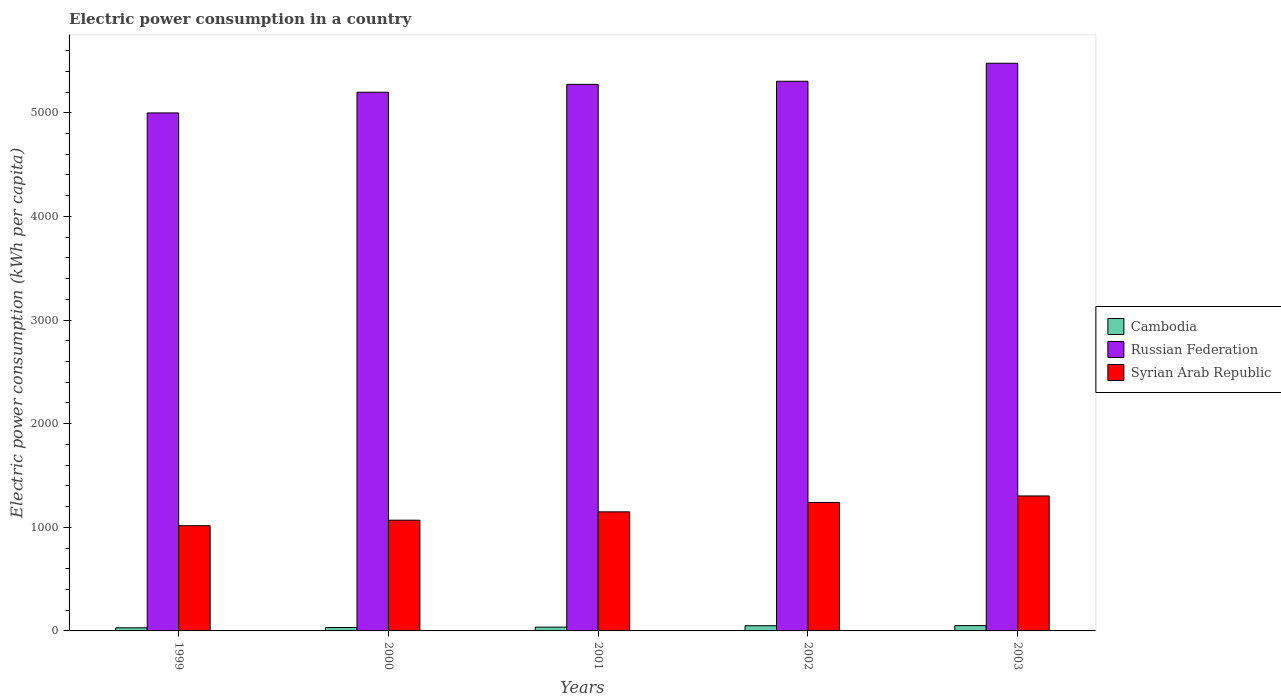How many different coloured bars are there?
Your response must be concise. 3. Are the number of bars on each tick of the X-axis equal?
Ensure brevity in your answer.  Yes. How many bars are there on the 3rd tick from the right?
Keep it short and to the point. 3. What is the electric power consumption in in Russian Federation in 2003?
Provide a succinct answer. 5478.14. Across all years, what is the maximum electric power consumption in in Cambodia?
Your response must be concise. 51.31. Across all years, what is the minimum electric power consumption in in Syrian Arab Republic?
Keep it short and to the point. 1015.69. In which year was the electric power consumption in in Syrian Arab Republic minimum?
Give a very brief answer. 1999. What is the total electric power consumption in in Syrian Arab Republic in the graph?
Keep it short and to the point. 5775.81. What is the difference between the electric power consumption in in Syrian Arab Republic in 2000 and that in 2001?
Offer a very short reply. -80.52. What is the difference between the electric power consumption in in Russian Federation in 2001 and the electric power consumption in in Cambodia in 2002?
Ensure brevity in your answer.  5224.23. What is the average electric power consumption in in Cambodia per year?
Ensure brevity in your answer.  40.12. In the year 2001, what is the difference between the electric power consumption in in Cambodia and electric power consumption in in Syrian Arab Republic?
Provide a succinct answer. -1112.74. In how many years, is the electric power consumption in in Russian Federation greater than 4600 kWh per capita?
Offer a very short reply. 5. What is the ratio of the electric power consumption in in Cambodia in 2000 to that in 2001?
Give a very brief answer. 0.9. What is the difference between the highest and the second highest electric power consumption in in Cambodia?
Provide a succinct answer. 1.16. What is the difference between the highest and the lowest electric power consumption in in Cambodia?
Keep it short and to the point. 21.22. Is the sum of the electric power consumption in in Russian Federation in 2000 and 2003 greater than the maximum electric power consumption in in Cambodia across all years?
Offer a terse response. Yes. What does the 2nd bar from the left in 2001 represents?
Your answer should be compact. Russian Federation. What does the 2nd bar from the right in 2003 represents?
Your answer should be very brief. Russian Federation. How many bars are there?
Your answer should be compact. 15. Are all the bars in the graph horizontal?
Ensure brevity in your answer.  No. How many years are there in the graph?
Make the answer very short. 5. What is the difference between two consecutive major ticks on the Y-axis?
Offer a very short reply. 1000. Does the graph contain any zero values?
Provide a succinct answer. No. Where does the legend appear in the graph?
Ensure brevity in your answer.  Center right. What is the title of the graph?
Offer a very short reply. Electric power consumption in a country. Does "Congo (Democratic)" appear as one of the legend labels in the graph?
Offer a terse response. No. What is the label or title of the X-axis?
Your answer should be very brief. Years. What is the label or title of the Y-axis?
Provide a short and direct response. Electric power consumption (kWh per capita). What is the Electric power consumption (kWh per capita) of Cambodia in 1999?
Keep it short and to the point. 30.1. What is the Electric power consumption (kWh per capita) of Russian Federation in 1999?
Your answer should be compact. 4998.84. What is the Electric power consumption (kWh per capita) of Syrian Arab Republic in 1999?
Ensure brevity in your answer.  1015.69. What is the Electric power consumption (kWh per capita) of Cambodia in 2000?
Keep it short and to the point. 32.63. What is the Electric power consumption (kWh per capita) in Russian Federation in 2000?
Your answer should be very brief. 5198.42. What is the Electric power consumption (kWh per capita) in Syrian Arab Republic in 2000?
Your answer should be compact. 1068.6. What is the Electric power consumption (kWh per capita) of Cambodia in 2001?
Provide a succinct answer. 36.39. What is the Electric power consumption (kWh per capita) in Russian Federation in 2001?
Offer a terse response. 5274.38. What is the Electric power consumption (kWh per capita) of Syrian Arab Republic in 2001?
Your response must be concise. 1149.13. What is the Electric power consumption (kWh per capita) of Cambodia in 2002?
Provide a succinct answer. 50.15. What is the Electric power consumption (kWh per capita) of Russian Federation in 2002?
Offer a terse response. 5304.43. What is the Electric power consumption (kWh per capita) of Syrian Arab Republic in 2002?
Give a very brief answer. 1239.89. What is the Electric power consumption (kWh per capita) in Cambodia in 2003?
Your answer should be very brief. 51.31. What is the Electric power consumption (kWh per capita) in Russian Federation in 2003?
Make the answer very short. 5478.14. What is the Electric power consumption (kWh per capita) of Syrian Arab Republic in 2003?
Make the answer very short. 1302.51. Across all years, what is the maximum Electric power consumption (kWh per capita) of Cambodia?
Your response must be concise. 51.31. Across all years, what is the maximum Electric power consumption (kWh per capita) of Russian Federation?
Give a very brief answer. 5478.14. Across all years, what is the maximum Electric power consumption (kWh per capita) of Syrian Arab Republic?
Your answer should be compact. 1302.51. Across all years, what is the minimum Electric power consumption (kWh per capita) of Cambodia?
Make the answer very short. 30.1. Across all years, what is the minimum Electric power consumption (kWh per capita) in Russian Federation?
Offer a very short reply. 4998.84. Across all years, what is the minimum Electric power consumption (kWh per capita) of Syrian Arab Republic?
Provide a short and direct response. 1015.69. What is the total Electric power consumption (kWh per capita) in Cambodia in the graph?
Your response must be concise. 200.58. What is the total Electric power consumption (kWh per capita) in Russian Federation in the graph?
Your answer should be very brief. 2.63e+04. What is the total Electric power consumption (kWh per capita) in Syrian Arab Republic in the graph?
Make the answer very short. 5775.81. What is the difference between the Electric power consumption (kWh per capita) in Cambodia in 1999 and that in 2000?
Provide a succinct answer. -2.53. What is the difference between the Electric power consumption (kWh per capita) in Russian Federation in 1999 and that in 2000?
Offer a very short reply. -199.58. What is the difference between the Electric power consumption (kWh per capita) in Syrian Arab Republic in 1999 and that in 2000?
Your response must be concise. -52.92. What is the difference between the Electric power consumption (kWh per capita) in Cambodia in 1999 and that in 2001?
Provide a short and direct response. -6.29. What is the difference between the Electric power consumption (kWh per capita) in Russian Federation in 1999 and that in 2001?
Provide a short and direct response. -275.54. What is the difference between the Electric power consumption (kWh per capita) in Syrian Arab Republic in 1999 and that in 2001?
Offer a very short reply. -133.44. What is the difference between the Electric power consumption (kWh per capita) of Cambodia in 1999 and that in 2002?
Your response must be concise. -20.05. What is the difference between the Electric power consumption (kWh per capita) of Russian Federation in 1999 and that in 2002?
Provide a short and direct response. -305.59. What is the difference between the Electric power consumption (kWh per capita) in Syrian Arab Republic in 1999 and that in 2002?
Give a very brief answer. -224.2. What is the difference between the Electric power consumption (kWh per capita) of Cambodia in 1999 and that in 2003?
Provide a succinct answer. -21.22. What is the difference between the Electric power consumption (kWh per capita) of Russian Federation in 1999 and that in 2003?
Provide a short and direct response. -479.31. What is the difference between the Electric power consumption (kWh per capita) in Syrian Arab Republic in 1999 and that in 2003?
Provide a short and direct response. -286.82. What is the difference between the Electric power consumption (kWh per capita) of Cambodia in 2000 and that in 2001?
Offer a very short reply. -3.76. What is the difference between the Electric power consumption (kWh per capita) of Russian Federation in 2000 and that in 2001?
Ensure brevity in your answer.  -75.96. What is the difference between the Electric power consumption (kWh per capita) of Syrian Arab Republic in 2000 and that in 2001?
Give a very brief answer. -80.52. What is the difference between the Electric power consumption (kWh per capita) in Cambodia in 2000 and that in 2002?
Provide a short and direct response. -17.52. What is the difference between the Electric power consumption (kWh per capita) of Russian Federation in 2000 and that in 2002?
Your response must be concise. -106.02. What is the difference between the Electric power consumption (kWh per capita) in Syrian Arab Republic in 2000 and that in 2002?
Keep it short and to the point. -171.28. What is the difference between the Electric power consumption (kWh per capita) of Cambodia in 2000 and that in 2003?
Your answer should be compact. -18.68. What is the difference between the Electric power consumption (kWh per capita) in Russian Federation in 2000 and that in 2003?
Offer a very short reply. -279.73. What is the difference between the Electric power consumption (kWh per capita) in Syrian Arab Republic in 2000 and that in 2003?
Offer a terse response. -233.9. What is the difference between the Electric power consumption (kWh per capita) in Cambodia in 2001 and that in 2002?
Your response must be concise. -13.76. What is the difference between the Electric power consumption (kWh per capita) of Russian Federation in 2001 and that in 2002?
Provide a short and direct response. -30.05. What is the difference between the Electric power consumption (kWh per capita) of Syrian Arab Republic in 2001 and that in 2002?
Provide a succinct answer. -90.76. What is the difference between the Electric power consumption (kWh per capita) of Cambodia in 2001 and that in 2003?
Offer a terse response. -14.92. What is the difference between the Electric power consumption (kWh per capita) of Russian Federation in 2001 and that in 2003?
Offer a very short reply. -203.77. What is the difference between the Electric power consumption (kWh per capita) in Syrian Arab Republic in 2001 and that in 2003?
Keep it short and to the point. -153.38. What is the difference between the Electric power consumption (kWh per capita) of Cambodia in 2002 and that in 2003?
Ensure brevity in your answer.  -1.16. What is the difference between the Electric power consumption (kWh per capita) of Russian Federation in 2002 and that in 2003?
Keep it short and to the point. -173.71. What is the difference between the Electric power consumption (kWh per capita) in Syrian Arab Republic in 2002 and that in 2003?
Ensure brevity in your answer.  -62.62. What is the difference between the Electric power consumption (kWh per capita) of Cambodia in 1999 and the Electric power consumption (kWh per capita) of Russian Federation in 2000?
Give a very brief answer. -5168.32. What is the difference between the Electric power consumption (kWh per capita) in Cambodia in 1999 and the Electric power consumption (kWh per capita) in Syrian Arab Republic in 2000?
Keep it short and to the point. -1038.51. What is the difference between the Electric power consumption (kWh per capita) in Russian Federation in 1999 and the Electric power consumption (kWh per capita) in Syrian Arab Republic in 2000?
Provide a succinct answer. 3930.23. What is the difference between the Electric power consumption (kWh per capita) in Cambodia in 1999 and the Electric power consumption (kWh per capita) in Russian Federation in 2001?
Provide a succinct answer. -5244.28. What is the difference between the Electric power consumption (kWh per capita) of Cambodia in 1999 and the Electric power consumption (kWh per capita) of Syrian Arab Republic in 2001?
Keep it short and to the point. -1119.03. What is the difference between the Electric power consumption (kWh per capita) in Russian Federation in 1999 and the Electric power consumption (kWh per capita) in Syrian Arab Republic in 2001?
Offer a very short reply. 3849.71. What is the difference between the Electric power consumption (kWh per capita) of Cambodia in 1999 and the Electric power consumption (kWh per capita) of Russian Federation in 2002?
Make the answer very short. -5274.34. What is the difference between the Electric power consumption (kWh per capita) of Cambodia in 1999 and the Electric power consumption (kWh per capita) of Syrian Arab Republic in 2002?
Your response must be concise. -1209.79. What is the difference between the Electric power consumption (kWh per capita) in Russian Federation in 1999 and the Electric power consumption (kWh per capita) in Syrian Arab Republic in 2002?
Keep it short and to the point. 3758.95. What is the difference between the Electric power consumption (kWh per capita) in Cambodia in 1999 and the Electric power consumption (kWh per capita) in Russian Federation in 2003?
Your answer should be very brief. -5448.05. What is the difference between the Electric power consumption (kWh per capita) in Cambodia in 1999 and the Electric power consumption (kWh per capita) in Syrian Arab Republic in 2003?
Your response must be concise. -1272.41. What is the difference between the Electric power consumption (kWh per capita) of Russian Federation in 1999 and the Electric power consumption (kWh per capita) of Syrian Arab Republic in 2003?
Offer a very short reply. 3696.33. What is the difference between the Electric power consumption (kWh per capita) of Cambodia in 2000 and the Electric power consumption (kWh per capita) of Russian Federation in 2001?
Make the answer very short. -5241.75. What is the difference between the Electric power consumption (kWh per capita) in Cambodia in 2000 and the Electric power consumption (kWh per capita) in Syrian Arab Republic in 2001?
Your answer should be compact. -1116.5. What is the difference between the Electric power consumption (kWh per capita) in Russian Federation in 2000 and the Electric power consumption (kWh per capita) in Syrian Arab Republic in 2001?
Your answer should be compact. 4049.29. What is the difference between the Electric power consumption (kWh per capita) of Cambodia in 2000 and the Electric power consumption (kWh per capita) of Russian Federation in 2002?
Provide a succinct answer. -5271.8. What is the difference between the Electric power consumption (kWh per capita) in Cambodia in 2000 and the Electric power consumption (kWh per capita) in Syrian Arab Republic in 2002?
Your answer should be compact. -1207.26. What is the difference between the Electric power consumption (kWh per capita) of Russian Federation in 2000 and the Electric power consumption (kWh per capita) of Syrian Arab Republic in 2002?
Offer a very short reply. 3958.53. What is the difference between the Electric power consumption (kWh per capita) of Cambodia in 2000 and the Electric power consumption (kWh per capita) of Russian Federation in 2003?
Provide a succinct answer. -5445.52. What is the difference between the Electric power consumption (kWh per capita) of Cambodia in 2000 and the Electric power consumption (kWh per capita) of Syrian Arab Republic in 2003?
Offer a terse response. -1269.88. What is the difference between the Electric power consumption (kWh per capita) in Russian Federation in 2000 and the Electric power consumption (kWh per capita) in Syrian Arab Republic in 2003?
Provide a succinct answer. 3895.91. What is the difference between the Electric power consumption (kWh per capita) in Cambodia in 2001 and the Electric power consumption (kWh per capita) in Russian Federation in 2002?
Your response must be concise. -5268.04. What is the difference between the Electric power consumption (kWh per capita) of Cambodia in 2001 and the Electric power consumption (kWh per capita) of Syrian Arab Republic in 2002?
Your response must be concise. -1203.5. What is the difference between the Electric power consumption (kWh per capita) of Russian Federation in 2001 and the Electric power consumption (kWh per capita) of Syrian Arab Republic in 2002?
Provide a short and direct response. 4034.49. What is the difference between the Electric power consumption (kWh per capita) in Cambodia in 2001 and the Electric power consumption (kWh per capita) in Russian Federation in 2003?
Your answer should be very brief. -5441.76. What is the difference between the Electric power consumption (kWh per capita) of Cambodia in 2001 and the Electric power consumption (kWh per capita) of Syrian Arab Republic in 2003?
Your answer should be compact. -1266.12. What is the difference between the Electric power consumption (kWh per capita) of Russian Federation in 2001 and the Electric power consumption (kWh per capita) of Syrian Arab Republic in 2003?
Provide a succinct answer. 3971.87. What is the difference between the Electric power consumption (kWh per capita) in Cambodia in 2002 and the Electric power consumption (kWh per capita) in Russian Federation in 2003?
Provide a succinct answer. -5427.99. What is the difference between the Electric power consumption (kWh per capita) in Cambodia in 2002 and the Electric power consumption (kWh per capita) in Syrian Arab Republic in 2003?
Provide a succinct answer. -1252.36. What is the difference between the Electric power consumption (kWh per capita) in Russian Federation in 2002 and the Electric power consumption (kWh per capita) in Syrian Arab Republic in 2003?
Give a very brief answer. 4001.93. What is the average Electric power consumption (kWh per capita) in Cambodia per year?
Offer a terse response. 40.12. What is the average Electric power consumption (kWh per capita) in Russian Federation per year?
Ensure brevity in your answer.  5250.84. What is the average Electric power consumption (kWh per capita) in Syrian Arab Republic per year?
Offer a terse response. 1155.16. In the year 1999, what is the difference between the Electric power consumption (kWh per capita) of Cambodia and Electric power consumption (kWh per capita) of Russian Federation?
Ensure brevity in your answer.  -4968.74. In the year 1999, what is the difference between the Electric power consumption (kWh per capita) in Cambodia and Electric power consumption (kWh per capita) in Syrian Arab Republic?
Give a very brief answer. -985.59. In the year 1999, what is the difference between the Electric power consumption (kWh per capita) in Russian Federation and Electric power consumption (kWh per capita) in Syrian Arab Republic?
Provide a succinct answer. 3983.15. In the year 2000, what is the difference between the Electric power consumption (kWh per capita) in Cambodia and Electric power consumption (kWh per capita) in Russian Federation?
Provide a succinct answer. -5165.79. In the year 2000, what is the difference between the Electric power consumption (kWh per capita) in Cambodia and Electric power consumption (kWh per capita) in Syrian Arab Republic?
Provide a succinct answer. -1035.98. In the year 2000, what is the difference between the Electric power consumption (kWh per capita) of Russian Federation and Electric power consumption (kWh per capita) of Syrian Arab Republic?
Your response must be concise. 4129.81. In the year 2001, what is the difference between the Electric power consumption (kWh per capita) in Cambodia and Electric power consumption (kWh per capita) in Russian Federation?
Your response must be concise. -5237.99. In the year 2001, what is the difference between the Electric power consumption (kWh per capita) of Cambodia and Electric power consumption (kWh per capita) of Syrian Arab Republic?
Keep it short and to the point. -1112.74. In the year 2001, what is the difference between the Electric power consumption (kWh per capita) of Russian Federation and Electric power consumption (kWh per capita) of Syrian Arab Republic?
Your response must be concise. 4125.25. In the year 2002, what is the difference between the Electric power consumption (kWh per capita) in Cambodia and Electric power consumption (kWh per capita) in Russian Federation?
Offer a terse response. -5254.28. In the year 2002, what is the difference between the Electric power consumption (kWh per capita) in Cambodia and Electric power consumption (kWh per capita) in Syrian Arab Republic?
Ensure brevity in your answer.  -1189.74. In the year 2002, what is the difference between the Electric power consumption (kWh per capita) of Russian Federation and Electric power consumption (kWh per capita) of Syrian Arab Republic?
Provide a short and direct response. 4064.55. In the year 2003, what is the difference between the Electric power consumption (kWh per capita) in Cambodia and Electric power consumption (kWh per capita) in Russian Federation?
Offer a very short reply. -5426.83. In the year 2003, what is the difference between the Electric power consumption (kWh per capita) of Cambodia and Electric power consumption (kWh per capita) of Syrian Arab Republic?
Your response must be concise. -1251.19. In the year 2003, what is the difference between the Electric power consumption (kWh per capita) of Russian Federation and Electric power consumption (kWh per capita) of Syrian Arab Republic?
Make the answer very short. 4175.64. What is the ratio of the Electric power consumption (kWh per capita) of Cambodia in 1999 to that in 2000?
Provide a succinct answer. 0.92. What is the ratio of the Electric power consumption (kWh per capita) in Russian Federation in 1999 to that in 2000?
Provide a short and direct response. 0.96. What is the ratio of the Electric power consumption (kWh per capita) of Syrian Arab Republic in 1999 to that in 2000?
Ensure brevity in your answer.  0.95. What is the ratio of the Electric power consumption (kWh per capita) of Cambodia in 1999 to that in 2001?
Offer a very short reply. 0.83. What is the ratio of the Electric power consumption (kWh per capita) of Russian Federation in 1999 to that in 2001?
Give a very brief answer. 0.95. What is the ratio of the Electric power consumption (kWh per capita) in Syrian Arab Republic in 1999 to that in 2001?
Provide a short and direct response. 0.88. What is the ratio of the Electric power consumption (kWh per capita) in Cambodia in 1999 to that in 2002?
Offer a terse response. 0.6. What is the ratio of the Electric power consumption (kWh per capita) in Russian Federation in 1999 to that in 2002?
Make the answer very short. 0.94. What is the ratio of the Electric power consumption (kWh per capita) in Syrian Arab Republic in 1999 to that in 2002?
Give a very brief answer. 0.82. What is the ratio of the Electric power consumption (kWh per capita) of Cambodia in 1999 to that in 2003?
Offer a terse response. 0.59. What is the ratio of the Electric power consumption (kWh per capita) of Russian Federation in 1999 to that in 2003?
Keep it short and to the point. 0.91. What is the ratio of the Electric power consumption (kWh per capita) of Syrian Arab Republic in 1999 to that in 2003?
Your answer should be compact. 0.78. What is the ratio of the Electric power consumption (kWh per capita) in Cambodia in 2000 to that in 2001?
Provide a succinct answer. 0.9. What is the ratio of the Electric power consumption (kWh per capita) of Russian Federation in 2000 to that in 2001?
Keep it short and to the point. 0.99. What is the ratio of the Electric power consumption (kWh per capita) in Syrian Arab Republic in 2000 to that in 2001?
Your answer should be compact. 0.93. What is the ratio of the Electric power consumption (kWh per capita) in Cambodia in 2000 to that in 2002?
Give a very brief answer. 0.65. What is the ratio of the Electric power consumption (kWh per capita) in Syrian Arab Republic in 2000 to that in 2002?
Your answer should be compact. 0.86. What is the ratio of the Electric power consumption (kWh per capita) of Cambodia in 2000 to that in 2003?
Ensure brevity in your answer.  0.64. What is the ratio of the Electric power consumption (kWh per capita) of Russian Federation in 2000 to that in 2003?
Offer a very short reply. 0.95. What is the ratio of the Electric power consumption (kWh per capita) of Syrian Arab Republic in 2000 to that in 2003?
Offer a terse response. 0.82. What is the ratio of the Electric power consumption (kWh per capita) of Cambodia in 2001 to that in 2002?
Provide a short and direct response. 0.73. What is the ratio of the Electric power consumption (kWh per capita) of Russian Federation in 2001 to that in 2002?
Make the answer very short. 0.99. What is the ratio of the Electric power consumption (kWh per capita) in Syrian Arab Republic in 2001 to that in 2002?
Provide a short and direct response. 0.93. What is the ratio of the Electric power consumption (kWh per capita) of Cambodia in 2001 to that in 2003?
Keep it short and to the point. 0.71. What is the ratio of the Electric power consumption (kWh per capita) of Russian Federation in 2001 to that in 2003?
Keep it short and to the point. 0.96. What is the ratio of the Electric power consumption (kWh per capita) in Syrian Arab Republic in 2001 to that in 2003?
Provide a succinct answer. 0.88. What is the ratio of the Electric power consumption (kWh per capita) in Cambodia in 2002 to that in 2003?
Your response must be concise. 0.98. What is the ratio of the Electric power consumption (kWh per capita) of Russian Federation in 2002 to that in 2003?
Your answer should be compact. 0.97. What is the ratio of the Electric power consumption (kWh per capita) in Syrian Arab Republic in 2002 to that in 2003?
Offer a terse response. 0.95. What is the difference between the highest and the second highest Electric power consumption (kWh per capita) in Cambodia?
Provide a succinct answer. 1.16. What is the difference between the highest and the second highest Electric power consumption (kWh per capita) of Russian Federation?
Your answer should be compact. 173.71. What is the difference between the highest and the second highest Electric power consumption (kWh per capita) in Syrian Arab Republic?
Keep it short and to the point. 62.62. What is the difference between the highest and the lowest Electric power consumption (kWh per capita) of Cambodia?
Provide a succinct answer. 21.22. What is the difference between the highest and the lowest Electric power consumption (kWh per capita) of Russian Federation?
Your answer should be compact. 479.31. What is the difference between the highest and the lowest Electric power consumption (kWh per capita) of Syrian Arab Republic?
Provide a succinct answer. 286.82. 